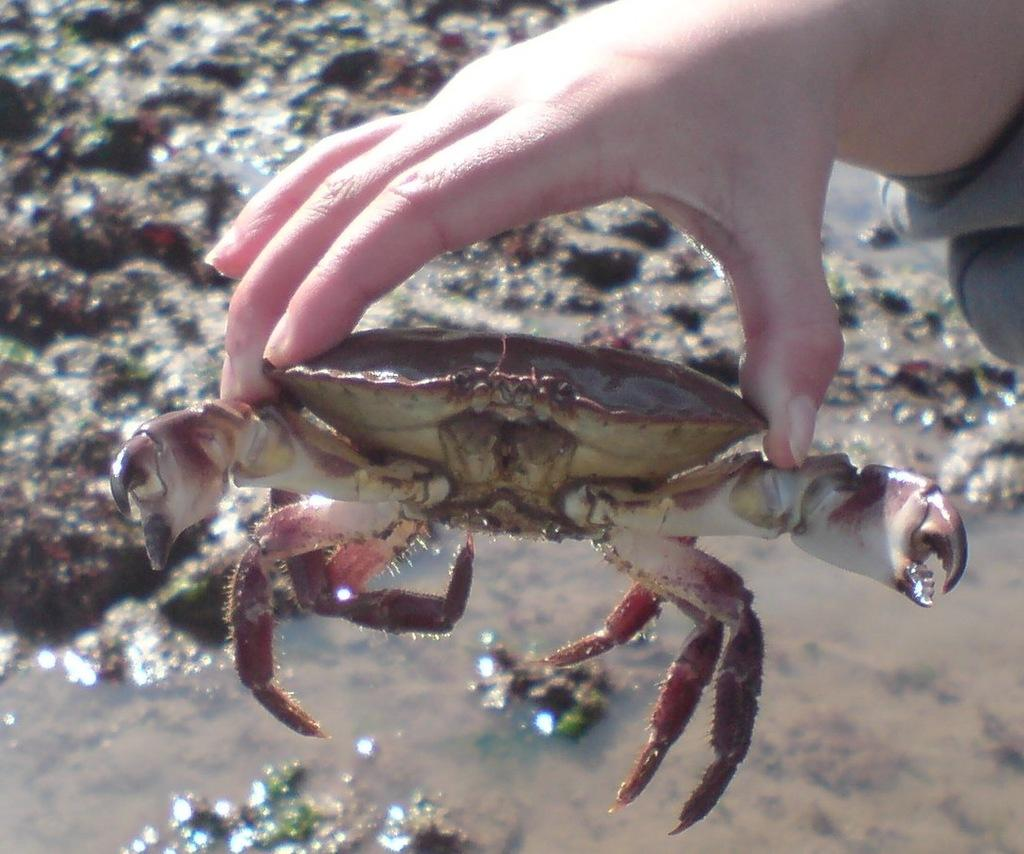What is the person in the image holding? The person is holding a crab. What type of environment is visible in the image? There is water visible in the image, suggesting a water-based environment. What is present on the floor in the image? There is mud on the floor in the image. Is there a parcel being delivered in the image? There is no mention or indication of a parcel being delivered in the image. What type of vegetable is being grown in the image? There is no vegetable being grown in the image; it features a person holding a crab in a water-based environment. 